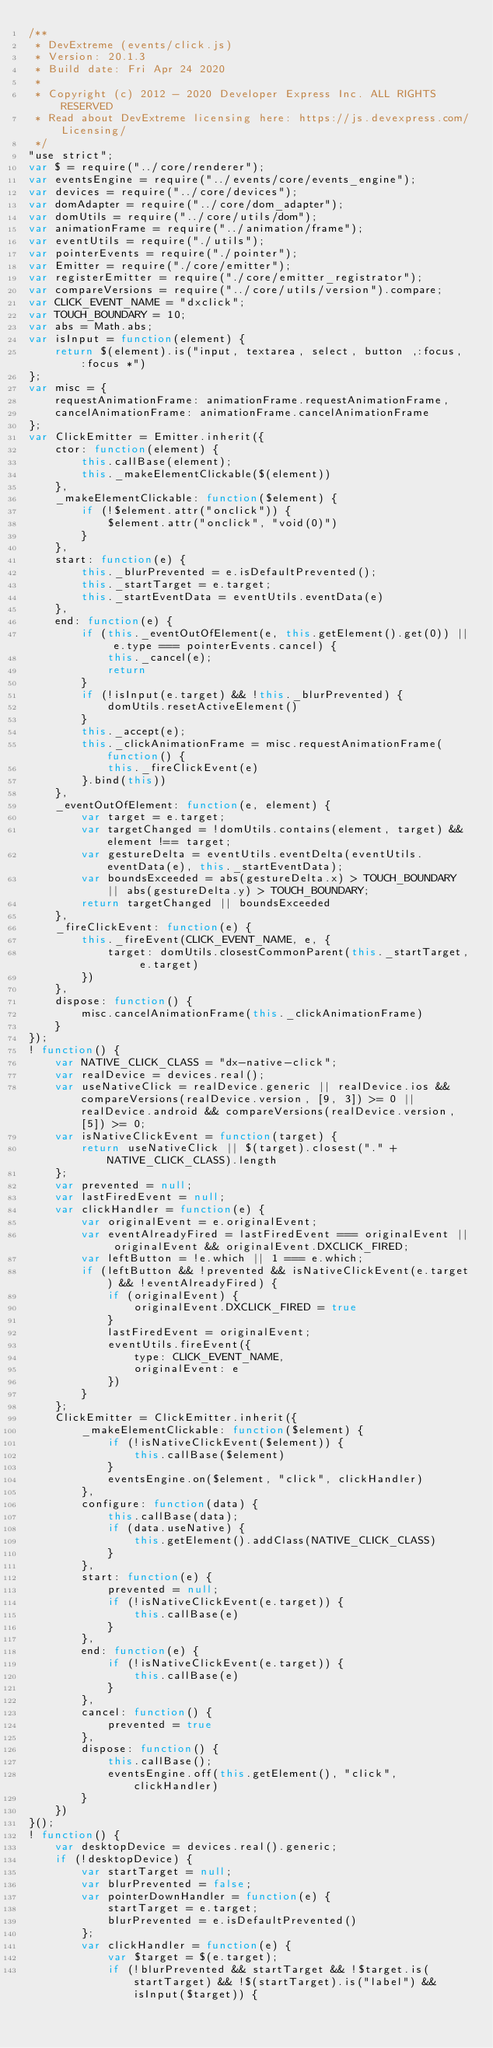<code> <loc_0><loc_0><loc_500><loc_500><_JavaScript_>/**
 * DevExtreme (events/click.js)
 * Version: 20.1.3
 * Build date: Fri Apr 24 2020
 *
 * Copyright (c) 2012 - 2020 Developer Express Inc. ALL RIGHTS RESERVED
 * Read about DevExtreme licensing here: https://js.devexpress.com/Licensing/
 */
"use strict";
var $ = require("../core/renderer");
var eventsEngine = require("../events/core/events_engine");
var devices = require("../core/devices");
var domAdapter = require("../core/dom_adapter");
var domUtils = require("../core/utils/dom");
var animationFrame = require("../animation/frame");
var eventUtils = require("./utils");
var pointerEvents = require("./pointer");
var Emitter = require("./core/emitter");
var registerEmitter = require("./core/emitter_registrator");
var compareVersions = require("../core/utils/version").compare;
var CLICK_EVENT_NAME = "dxclick";
var TOUCH_BOUNDARY = 10;
var abs = Math.abs;
var isInput = function(element) {
    return $(element).is("input, textarea, select, button ,:focus, :focus *")
};
var misc = {
    requestAnimationFrame: animationFrame.requestAnimationFrame,
    cancelAnimationFrame: animationFrame.cancelAnimationFrame
};
var ClickEmitter = Emitter.inherit({
    ctor: function(element) {
        this.callBase(element);
        this._makeElementClickable($(element))
    },
    _makeElementClickable: function($element) {
        if (!$element.attr("onclick")) {
            $element.attr("onclick", "void(0)")
        }
    },
    start: function(e) {
        this._blurPrevented = e.isDefaultPrevented();
        this._startTarget = e.target;
        this._startEventData = eventUtils.eventData(e)
    },
    end: function(e) {
        if (this._eventOutOfElement(e, this.getElement().get(0)) || e.type === pointerEvents.cancel) {
            this._cancel(e);
            return
        }
        if (!isInput(e.target) && !this._blurPrevented) {
            domUtils.resetActiveElement()
        }
        this._accept(e);
        this._clickAnimationFrame = misc.requestAnimationFrame(function() {
            this._fireClickEvent(e)
        }.bind(this))
    },
    _eventOutOfElement: function(e, element) {
        var target = e.target;
        var targetChanged = !domUtils.contains(element, target) && element !== target;
        var gestureDelta = eventUtils.eventDelta(eventUtils.eventData(e), this._startEventData);
        var boundsExceeded = abs(gestureDelta.x) > TOUCH_BOUNDARY || abs(gestureDelta.y) > TOUCH_BOUNDARY;
        return targetChanged || boundsExceeded
    },
    _fireClickEvent: function(e) {
        this._fireEvent(CLICK_EVENT_NAME, e, {
            target: domUtils.closestCommonParent(this._startTarget, e.target)
        })
    },
    dispose: function() {
        misc.cancelAnimationFrame(this._clickAnimationFrame)
    }
});
! function() {
    var NATIVE_CLICK_CLASS = "dx-native-click";
    var realDevice = devices.real();
    var useNativeClick = realDevice.generic || realDevice.ios && compareVersions(realDevice.version, [9, 3]) >= 0 || realDevice.android && compareVersions(realDevice.version, [5]) >= 0;
    var isNativeClickEvent = function(target) {
        return useNativeClick || $(target).closest("." + NATIVE_CLICK_CLASS).length
    };
    var prevented = null;
    var lastFiredEvent = null;
    var clickHandler = function(e) {
        var originalEvent = e.originalEvent;
        var eventAlreadyFired = lastFiredEvent === originalEvent || originalEvent && originalEvent.DXCLICK_FIRED;
        var leftButton = !e.which || 1 === e.which;
        if (leftButton && !prevented && isNativeClickEvent(e.target) && !eventAlreadyFired) {
            if (originalEvent) {
                originalEvent.DXCLICK_FIRED = true
            }
            lastFiredEvent = originalEvent;
            eventUtils.fireEvent({
                type: CLICK_EVENT_NAME,
                originalEvent: e
            })
        }
    };
    ClickEmitter = ClickEmitter.inherit({
        _makeElementClickable: function($element) {
            if (!isNativeClickEvent($element)) {
                this.callBase($element)
            }
            eventsEngine.on($element, "click", clickHandler)
        },
        configure: function(data) {
            this.callBase(data);
            if (data.useNative) {
                this.getElement().addClass(NATIVE_CLICK_CLASS)
            }
        },
        start: function(e) {
            prevented = null;
            if (!isNativeClickEvent(e.target)) {
                this.callBase(e)
            }
        },
        end: function(e) {
            if (!isNativeClickEvent(e.target)) {
                this.callBase(e)
            }
        },
        cancel: function() {
            prevented = true
        },
        dispose: function() {
            this.callBase();
            eventsEngine.off(this.getElement(), "click", clickHandler)
        }
    })
}();
! function() {
    var desktopDevice = devices.real().generic;
    if (!desktopDevice) {
        var startTarget = null;
        var blurPrevented = false;
        var pointerDownHandler = function(e) {
            startTarget = e.target;
            blurPrevented = e.isDefaultPrevented()
        };
        var clickHandler = function(e) {
            var $target = $(e.target);
            if (!blurPrevented && startTarget && !$target.is(startTarget) && !$(startTarget).is("label") && isInput($target)) {</code> 